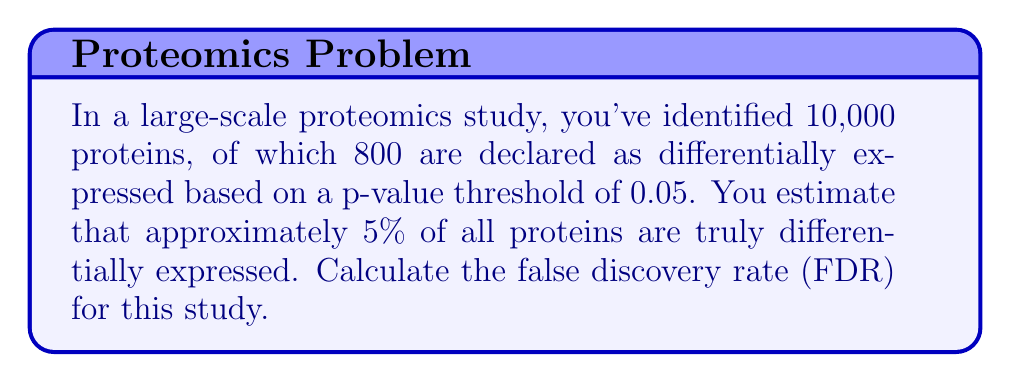Help me with this question. To solve this problem, we need to understand the concept of false discovery rate and how to calculate it using the given information. Let's break it down step-by-step:

1. First, let's define our variables:
   - Total proteins identified: $N = 10,000$
   - Proteins declared as differentially expressed: $D = 800$
   - Estimated truly differentially expressed proteins: $5\% \text{ of } N = 0.05 \times 10,000 = 500$

2. The false discovery rate (FDR) is defined as the expected proportion of false positives among all significant calls. It can be calculated as:

   $$ FDR = \frac{\text{Number of False Positives}}{\text{Total Number of Positives}} $$

3. To estimate the number of false positives, we need to:
   a. Calculate the number of true positives (TP)
   b. Subtract TP from the total number of proteins declared as differentially expressed

4. True positives (TP) are the correctly identified differentially expressed proteins. This is the smaller of:
   a. The number of proteins declared as differentially expressed (D)
   b. The estimated number of truly differentially expressed proteins

   $$ TP = \min(D, 500) = \min(800, 500) = 500 $$

5. Now we can calculate the number of false positives (FP):

   $$ FP = D - TP = 800 - 500 = 300 $$

6. Finally, we can calculate the FDR:

   $$ FDR = \frac{FP}{D} = \frac{300}{800} = 0.375 = 37.5\% $$

This means that approximately 37.5% of the proteins declared as differentially expressed are expected to be false positives.
Answer: The false discovery rate (FDR) for this proteomics study is 37.5%. 